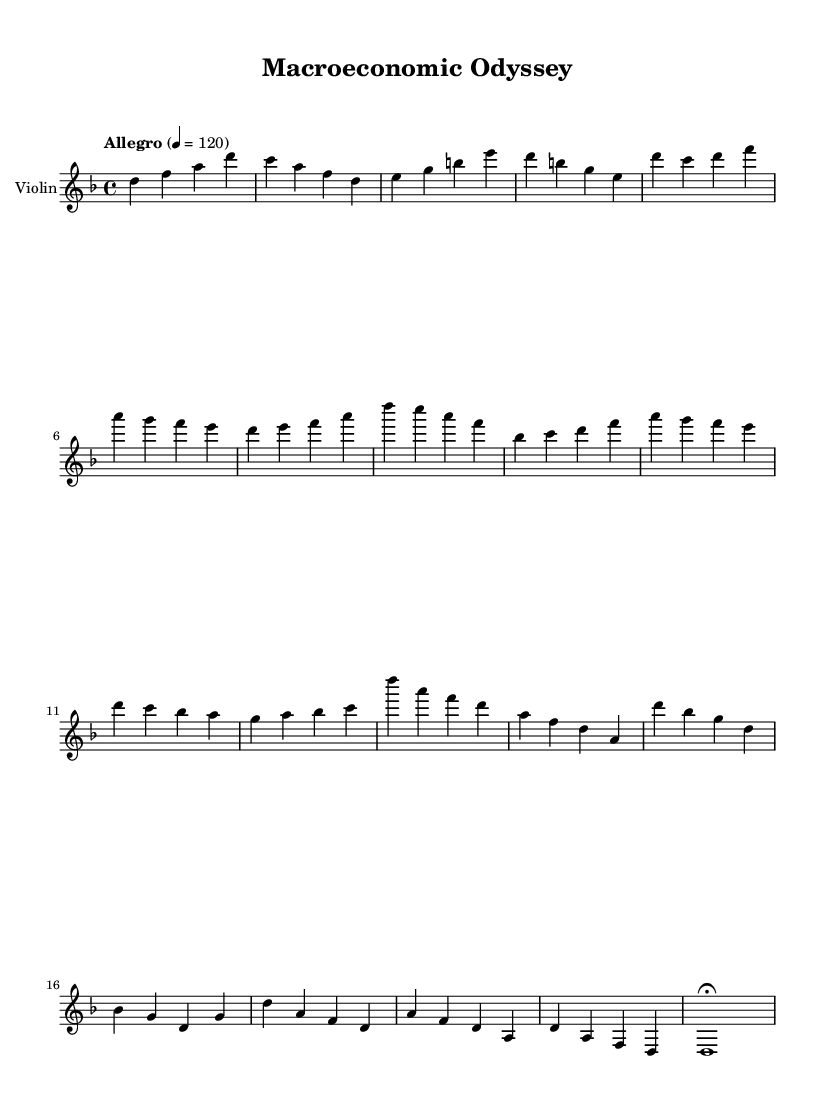What is the key signature of this music? The piece is in D minor, which consists of one flat (B flat). This can be determined by looking at the key signature indicated at the beginning of the staff.
Answer: D minor What is the time signature of this music? The time signature is 4/4, which indicates that there are four beats per measure and the quarter note gets one beat. This is explicitly stated at the beginning of the score.
Answer: 4/4 What is the tempo marking for this piece? The tempo marking is "Allegro" with a metronome marking of 120 beats per minute. This indicates a fast and lively pace for the music.
Answer: Allegro How many measures are in the main theme A? The main theme A consists of two measures in the shortened form, as seen after the introductory section. This can be counted by examining the music notes and the bar lines.
Answer: 2 What is the dynamic marking at the climax section? The climax does not have a specified dynamic marking within the provided code, but typically in orchestral music, climaxes are marked with dynamics like "forte" or are understood to be played with increased intensity.
Answer: (not specified) Which instrument is notated in this score? The score is for the violin, as explicitly labeled at the start of the staff. This can be confirmed by looking at the instrument name at the top of the staff.
Answer: Violin What is the last note of the outro section? The last note in the outro section is a D held for a whole note, as indicated by the notation at the end of the measure. This is seen by referencing the final measures in the provided sequence.
Answer: D 